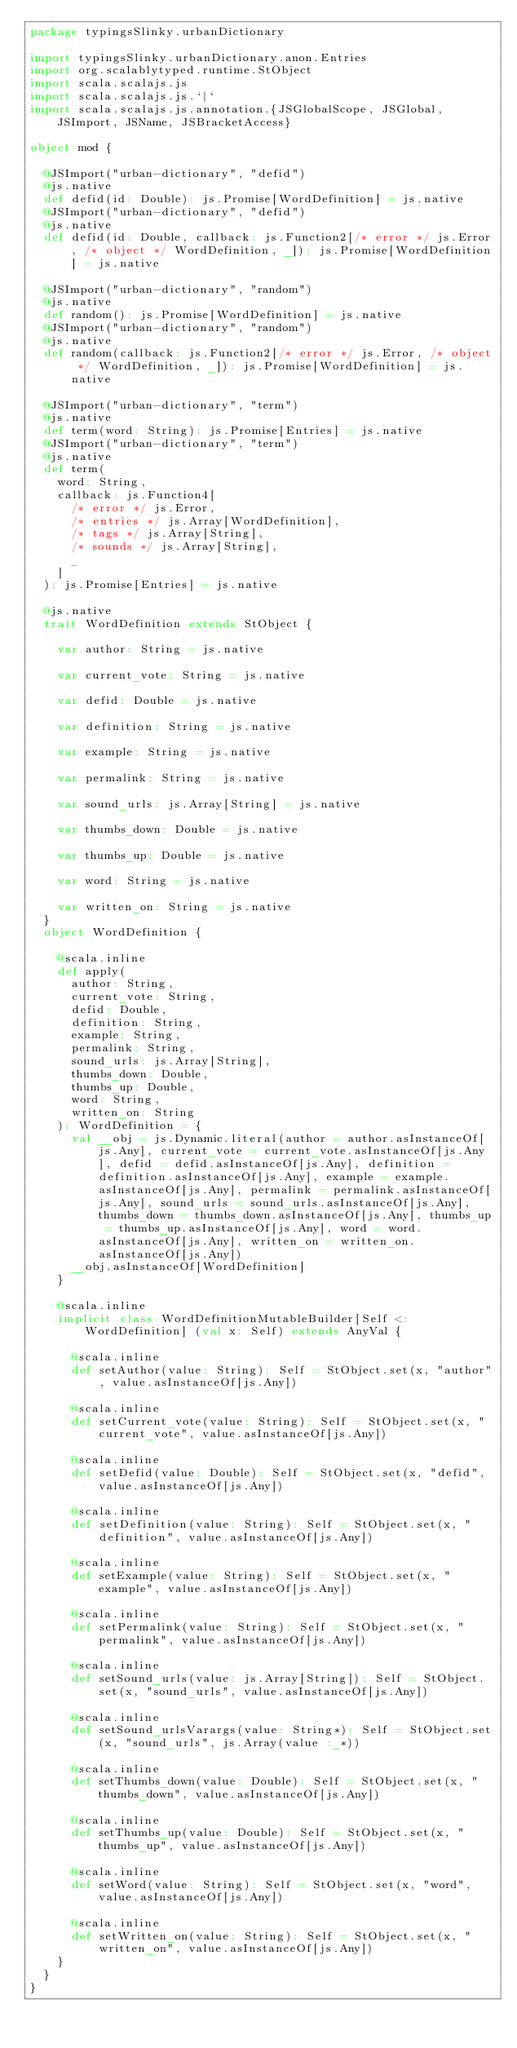Convert code to text. <code><loc_0><loc_0><loc_500><loc_500><_Scala_>package typingsSlinky.urbanDictionary

import typingsSlinky.urbanDictionary.anon.Entries
import org.scalablytyped.runtime.StObject
import scala.scalajs.js
import scala.scalajs.js.`|`
import scala.scalajs.js.annotation.{JSGlobalScope, JSGlobal, JSImport, JSName, JSBracketAccess}

object mod {
  
  @JSImport("urban-dictionary", "defid")
  @js.native
  def defid(id: Double): js.Promise[WordDefinition] = js.native
  @JSImport("urban-dictionary", "defid")
  @js.native
  def defid(id: Double, callback: js.Function2[/* error */ js.Error, /* object */ WordDefinition, _]): js.Promise[WordDefinition] = js.native
  
  @JSImport("urban-dictionary", "random")
  @js.native
  def random(): js.Promise[WordDefinition] = js.native
  @JSImport("urban-dictionary", "random")
  @js.native
  def random(callback: js.Function2[/* error */ js.Error, /* object */ WordDefinition, _]): js.Promise[WordDefinition] = js.native
  
  @JSImport("urban-dictionary", "term")
  @js.native
  def term(word: String): js.Promise[Entries] = js.native
  @JSImport("urban-dictionary", "term")
  @js.native
  def term(
    word: String,
    callback: js.Function4[
      /* error */ js.Error, 
      /* entries */ js.Array[WordDefinition], 
      /* tags */ js.Array[String], 
      /* sounds */ js.Array[String], 
      _
    ]
  ): js.Promise[Entries] = js.native
  
  @js.native
  trait WordDefinition extends StObject {
    
    var author: String = js.native
    
    var current_vote: String = js.native
    
    var defid: Double = js.native
    
    var definition: String = js.native
    
    var example: String = js.native
    
    var permalink: String = js.native
    
    var sound_urls: js.Array[String] = js.native
    
    var thumbs_down: Double = js.native
    
    var thumbs_up: Double = js.native
    
    var word: String = js.native
    
    var written_on: String = js.native
  }
  object WordDefinition {
    
    @scala.inline
    def apply(
      author: String,
      current_vote: String,
      defid: Double,
      definition: String,
      example: String,
      permalink: String,
      sound_urls: js.Array[String],
      thumbs_down: Double,
      thumbs_up: Double,
      word: String,
      written_on: String
    ): WordDefinition = {
      val __obj = js.Dynamic.literal(author = author.asInstanceOf[js.Any], current_vote = current_vote.asInstanceOf[js.Any], defid = defid.asInstanceOf[js.Any], definition = definition.asInstanceOf[js.Any], example = example.asInstanceOf[js.Any], permalink = permalink.asInstanceOf[js.Any], sound_urls = sound_urls.asInstanceOf[js.Any], thumbs_down = thumbs_down.asInstanceOf[js.Any], thumbs_up = thumbs_up.asInstanceOf[js.Any], word = word.asInstanceOf[js.Any], written_on = written_on.asInstanceOf[js.Any])
      __obj.asInstanceOf[WordDefinition]
    }
    
    @scala.inline
    implicit class WordDefinitionMutableBuilder[Self <: WordDefinition] (val x: Self) extends AnyVal {
      
      @scala.inline
      def setAuthor(value: String): Self = StObject.set(x, "author", value.asInstanceOf[js.Any])
      
      @scala.inline
      def setCurrent_vote(value: String): Self = StObject.set(x, "current_vote", value.asInstanceOf[js.Any])
      
      @scala.inline
      def setDefid(value: Double): Self = StObject.set(x, "defid", value.asInstanceOf[js.Any])
      
      @scala.inline
      def setDefinition(value: String): Self = StObject.set(x, "definition", value.asInstanceOf[js.Any])
      
      @scala.inline
      def setExample(value: String): Self = StObject.set(x, "example", value.asInstanceOf[js.Any])
      
      @scala.inline
      def setPermalink(value: String): Self = StObject.set(x, "permalink", value.asInstanceOf[js.Any])
      
      @scala.inline
      def setSound_urls(value: js.Array[String]): Self = StObject.set(x, "sound_urls", value.asInstanceOf[js.Any])
      
      @scala.inline
      def setSound_urlsVarargs(value: String*): Self = StObject.set(x, "sound_urls", js.Array(value :_*))
      
      @scala.inline
      def setThumbs_down(value: Double): Self = StObject.set(x, "thumbs_down", value.asInstanceOf[js.Any])
      
      @scala.inline
      def setThumbs_up(value: Double): Self = StObject.set(x, "thumbs_up", value.asInstanceOf[js.Any])
      
      @scala.inline
      def setWord(value: String): Self = StObject.set(x, "word", value.asInstanceOf[js.Any])
      
      @scala.inline
      def setWritten_on(value: String): Self = StObject.set(x, "written_on", value.asInstanceOf[js.Any])
    }
  }
}
</code> 